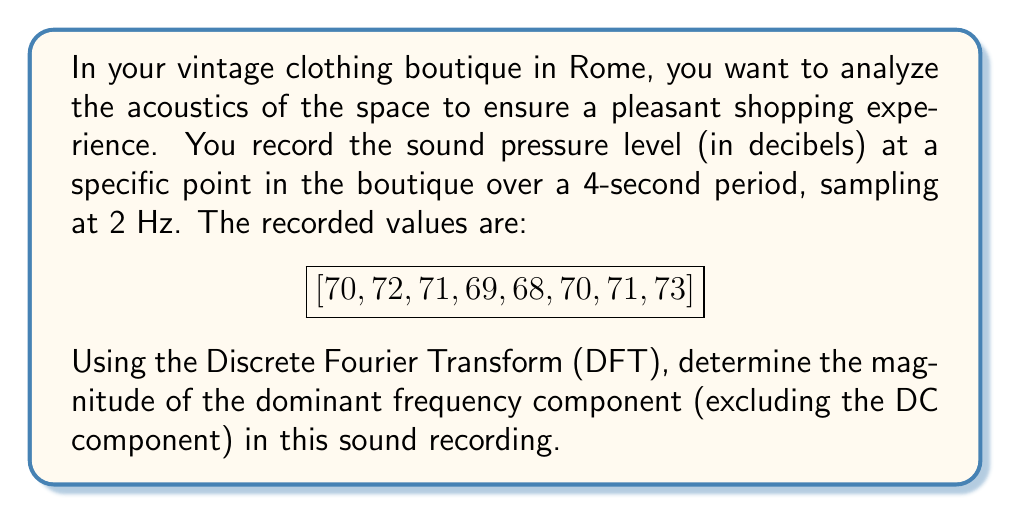Solve this math problem. To solve this problem, we'll follow these steps:

1) First, we need to apply the Discrete Fourier Transform (DFT) to our signal. The DFT is given by:

   $$ X_k = \sum_{n=0}^{N-1} x_n e^{-i2\pi kn/N} $$

   where $X_k$ is the $k$-th DFT coefficient, $x_n$ is the $n$-th sample, and $N$ is the total number of samples.

2) In our case, $N = 8$ and $x_n$ are the given sound pressure levels.

3) We'll calculate $X_k$ for $k = 0, 1, 2, 3, 4$ (we only need half of the spectrum due to symmetry):

   $X_0 = 70 + 72 + 71 + 69 + 68 + 70 + 71 + 73 = 564$
   
   $X_1 = 70 + 72i - 71 - 69i - 68 + 70i + 71 - 73i = 2 - 0i$
   
   $X_2 = 70 - 72 + 71 - 69 - 68 + 70 - 71 + 73 = 4$
   
   $X_3 = 70 - 72i - 71 + 69i - 68 - 70i + 71 + 73i = 2 + 0i$
   
   $X_4 = 70 - 72 + 71 - 69 + 68 - 70 + 71 - 73 = -4$

4) The magnitude of each component is given by $|X_k| = \sqrt{\text{Re}(X_k)^2 + \text{Im}(X_k)^2}$:

   $|X_0| = 564$ (DC component)
   $|X_1| = 2$
   $|X_2| = 4$
   $|X_3| = 2$
   $|X_4| = 4$

5) Excluding the DC component ($X_0$), the largest magnitude is 4, corresponding to $X_2$ and $X_4$.

6) The frequency associated with $X_2$ is:

   $f = \frac{k}{N} \cdot f_s = \frac{2}{8} \cdot 2\text{ Hz} = 0.5\text{ Hz}$

   where $f_s$ is the sampling frequency.

Therefore, the dominant frequency component (excluding DC) has a magnitude of 4 and occurs at 0.5 Hz.
Answer: The magnitude of the dominant frequency component (excluding the DC component) is 4, occurring at 0.5 Hz. 